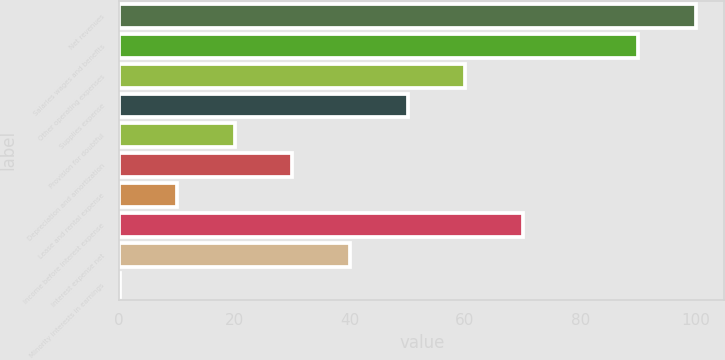Convert chart. <chart><loc_0><loc_0><loc_500><loc_500><bar_chart><fcel>Net revenues<fcel>Salaries wages and benefits<fcel>Other operating expenses<fcel>Supplies expense<fcel>Provision for doubtful<fcel>Depreciation and amortization<fcel>Lease and rental expense<fcel>Income before interest expense<fcel>Interest expense net<fcel>Minority interests in earnings<nl><fcel>100<fcel>90.01<fcel>60.04<fcel>50.05<fcel>20.08<fcel>30.07<fcel>10.09<fcel>70.03<fcel>40.06<fcel>0.1<nl></chart> 